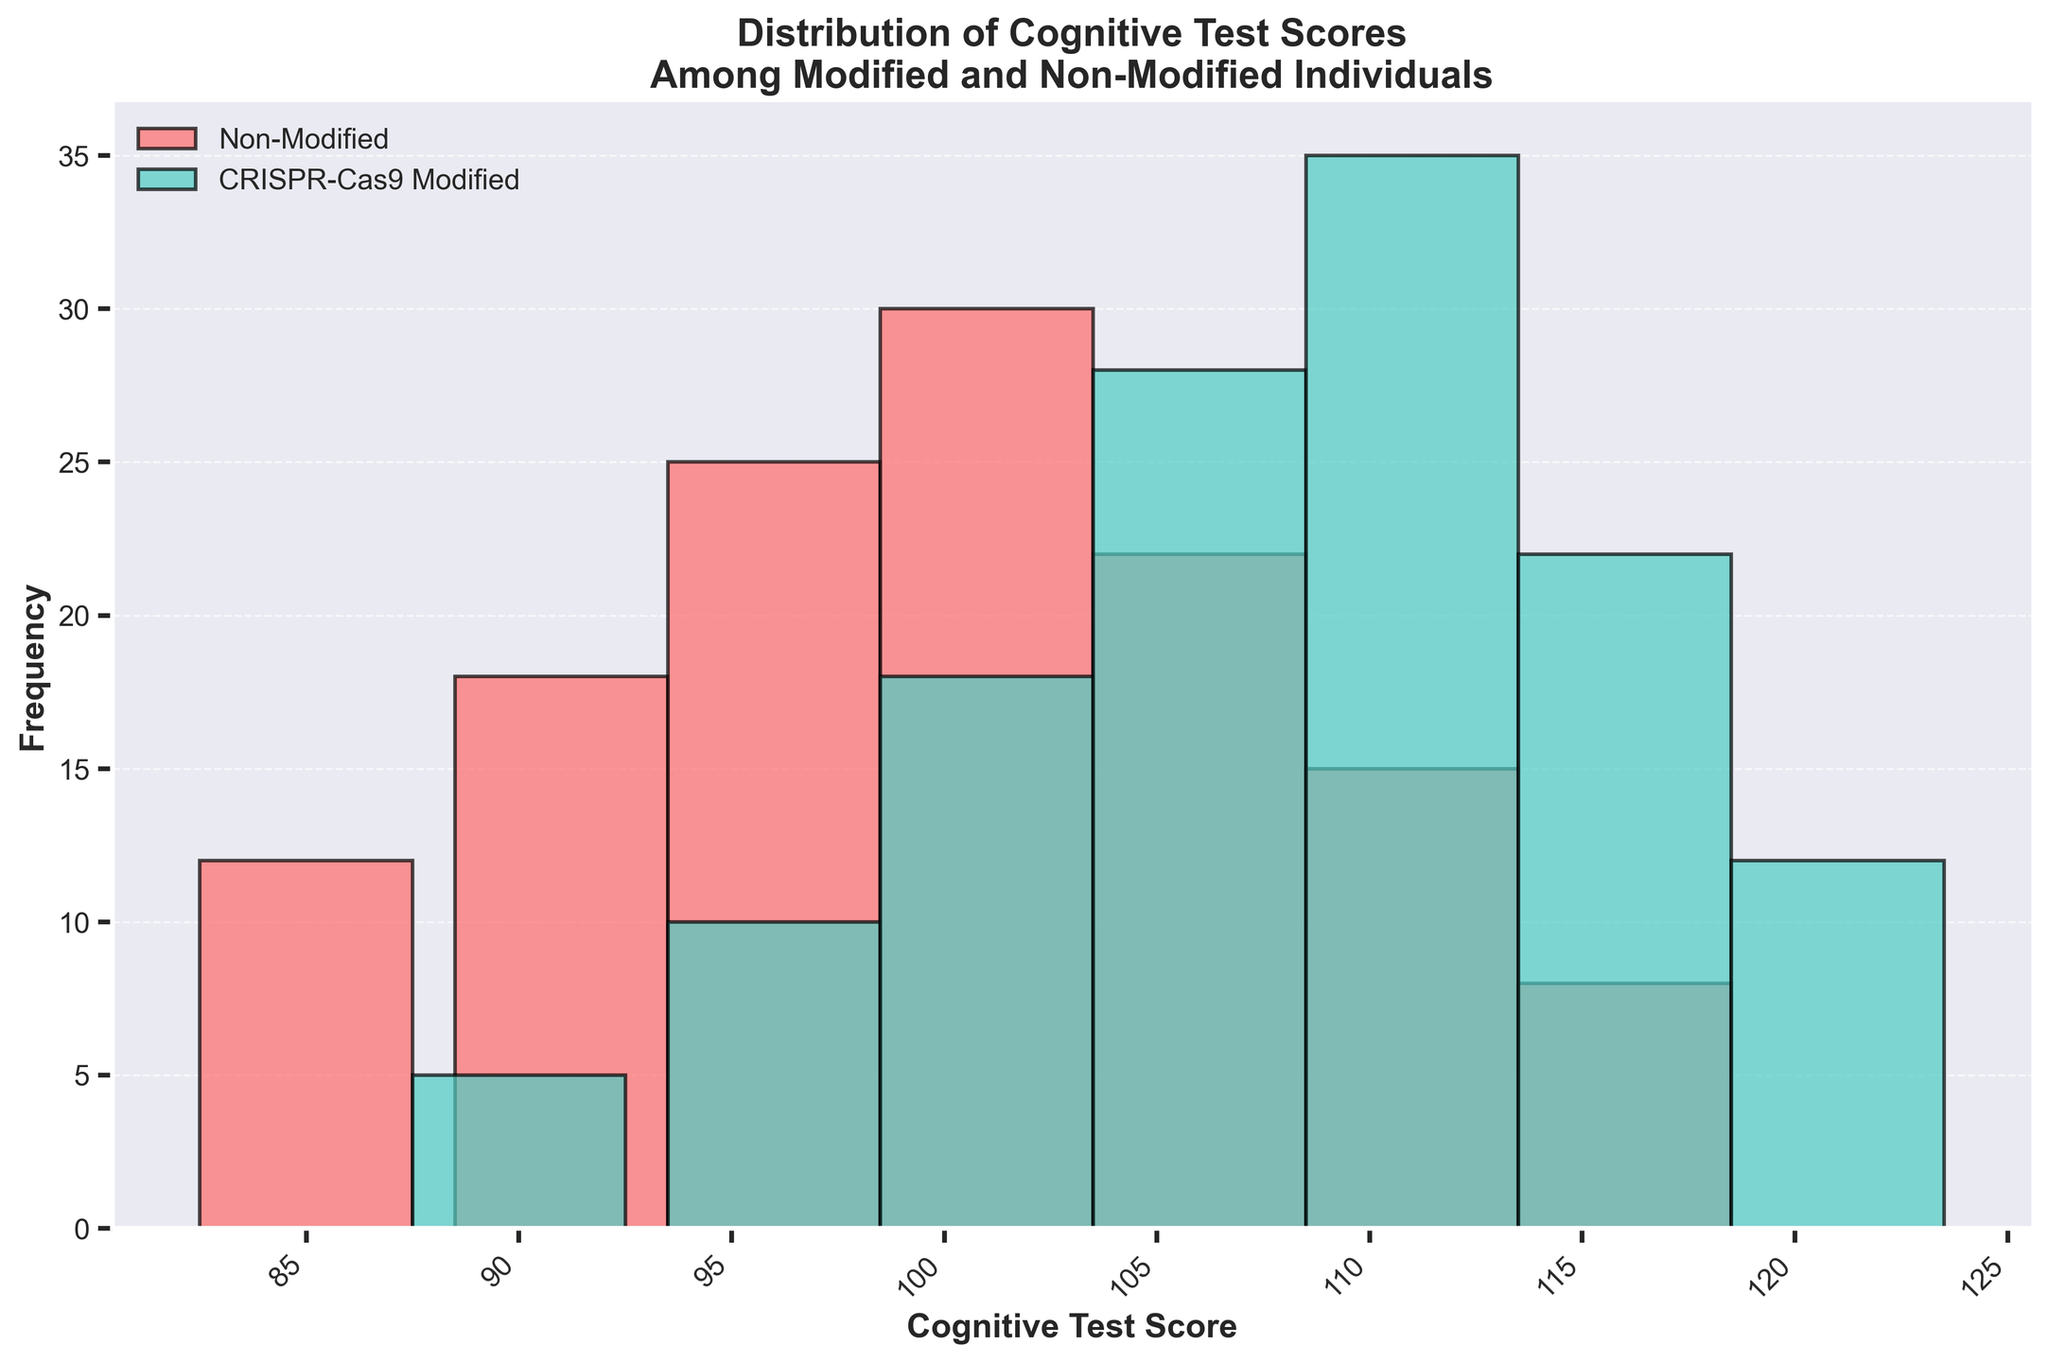What is the title of the figure? The title is usually located at the top of the figure, providing a brief description of what the figure represents. In this case, the title is "Distribution of Cognitive Test Scores Among Modified and Non-Modified Individuals" which indicates that the histogram shows the distribution of test scores for two groups: individuals with and without genetic modifications.
Answer: Distribution of Cognitive Test Scores Among Modified and Non-Modified Individuals Which cognitive test score range has the highest frequency for the CRISPR-Cas9 Modified group? To find the range with the highest frequency for the CRISPR-Cas9 Modified group, look for the tallest bar in the corresponding color for this group (usually green or teal). The tallest bar for this group is in the range 111-115, with a frequency of 35.
Answer: 111-115 How many more individuals in the 111-115 score range are in the CRISPR-Cas9 Modified group compared to the Non-Modified group? To find the difference, look at the frequencies for the 111-115 score range for both groups. The CRISPR-Cas9 Modified group has 35 individuals, and the Non-Modified group has 15 individuals. Subtract the Non-Modified frequency from the Modified frequency to get the difference: 35 - 15 = 20.
Answer: 20 What is the total number of individuals in the Non-Modified group based on the histogram? Sum the frequencies of all the bars for the Non-Modified group: 12 + 18 + 25 + 30 + 22 + 15 + 8 = 130.
Answer: 130 Which genetic group has a wider range of cognitive test scores? To compare the ranges, identify the lowest and highest score ranges for each group. The Non-Modified group ranges from 85-90 to 116-120, while the CRISPR-Cas9 Modified group ranges from 90-95 to 121-125. The CRISPR-Cas9 Modified group has a wider range.
Answer: CRISPR-Cas9 Modified What is the median cognitive test score range for the CRISPR-Cas9 Modified group? To find the median range, locate the middle value in the sorted list of frequencies for the CRISPR-Cas9 Modified group: [5, 10, 18, 28, 35, 22, 12]. The middle value is 28, corresponding to the score range 106-110.
Answer: 106-110 Which group has more individuals in the 101-105 score range? Compare the frequency bars for the 101-105 range in both groups. The Non-Modified group has 30 individuals, while the CRISPR-Cas9 Modified group has 18 individuals. The Non-Modified group has more individuals in this range.
Answer: Non-Modified How many score ranges have frequencies above 20 for the CRISPR-Cas9 Modified group? Look at the frequencies for all score ranges in the CRISPR-Cas9 group and count how many exceed 20: 106-110 (28), 111-115 (35), and 116-120 (22). There are 3 ranges above 20.
Answer: 3 What is the average frequency of individuals in the 96-100 score range for both groups combined? Add the frequencies of both groups in the 96-100 range and divide by 2: (25 in Non-Modified + 10 in CRISPR-Cas9 Modified) / 2 = 35 / 2 = 17.5.
Answer: 17.5 